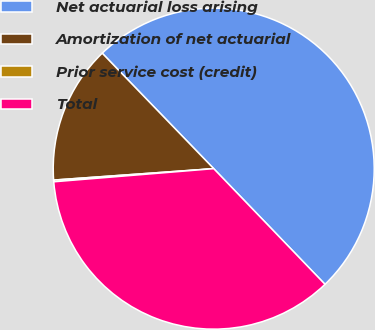<chart> <loc_0><loc_0><loc_500><loc_500><pie_chart><fcel>Net actuarial loss arising<fcel>Amortization of net actuarial<fcel>Prior service cost (credit)<fcel>Total<nl><fcel>50.03%<fcel>13.91%<fcel>0.17%<fcel>35.89%<nl></chart> 